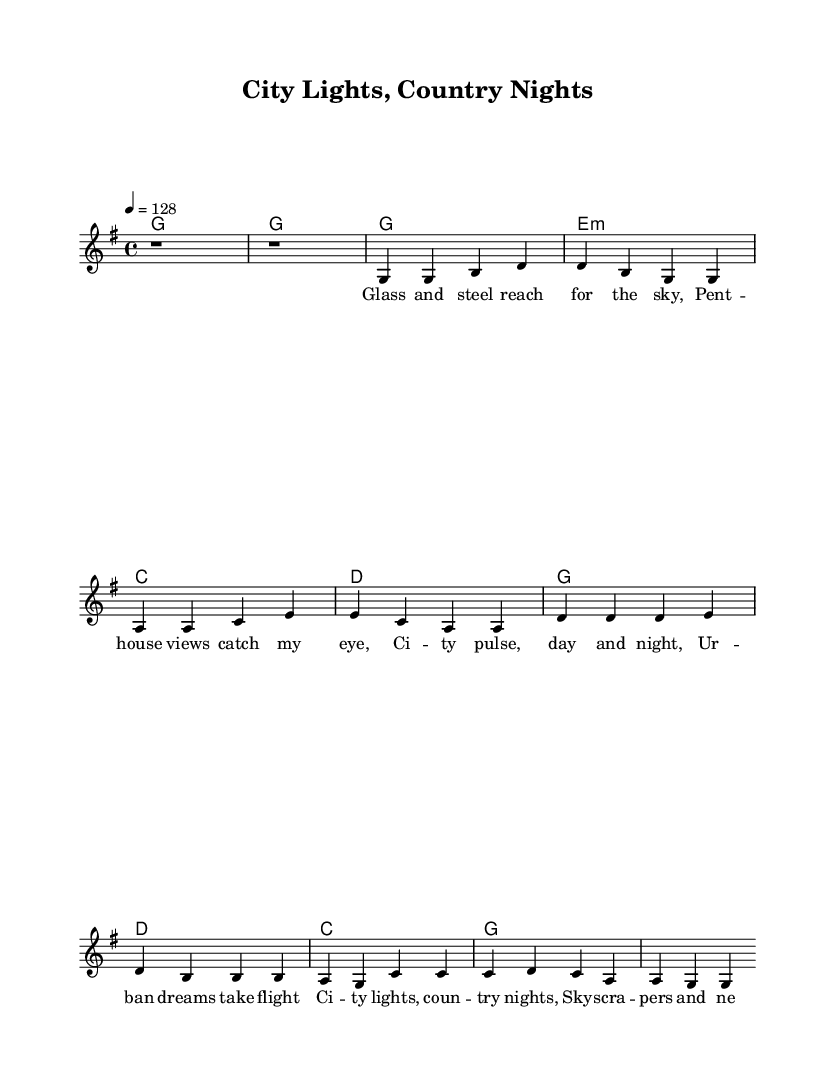What is the key signature of this music? The key signature is G major, which has one sharp (F#). This can be determined by looking at the key indication at the beginning of the score.
Answer: G major What is the time signature of the piece? The time signature is 4/4, which is represented by the "4/4" notation at the beginning of the score. This indicates that there are four beats per measure and a quarter note receives one beat.
Answer: 4/4 What is the tempo marking in this score? The tempo marking is 128, which is indicated by the "4 = 128" in the tempo directive. This means that the piece should be played at 128 beats per minute.
Answer: 128 Which section contains the lyrics about urban dreams? The section that contains lyrics about urban dreams is the verse. The verse words speak of the city skyline, dreams, and urban life.
Answer: Verse How many measures are there in the chorus? There are four measures in the chorus, which can be counted by examining the notation in the score specifically in the chorus section that consists of four lines of music.
Answer: Four What do the lyrics in the chorus reference? The lyrics in the chorus reference the contrast between city lights and country nights, indicating a theme of urban success and lifestyle juxtaposition. This suggests a common feature of country rock, combining rural and urban imagery.
Answer: City lights, country nights 